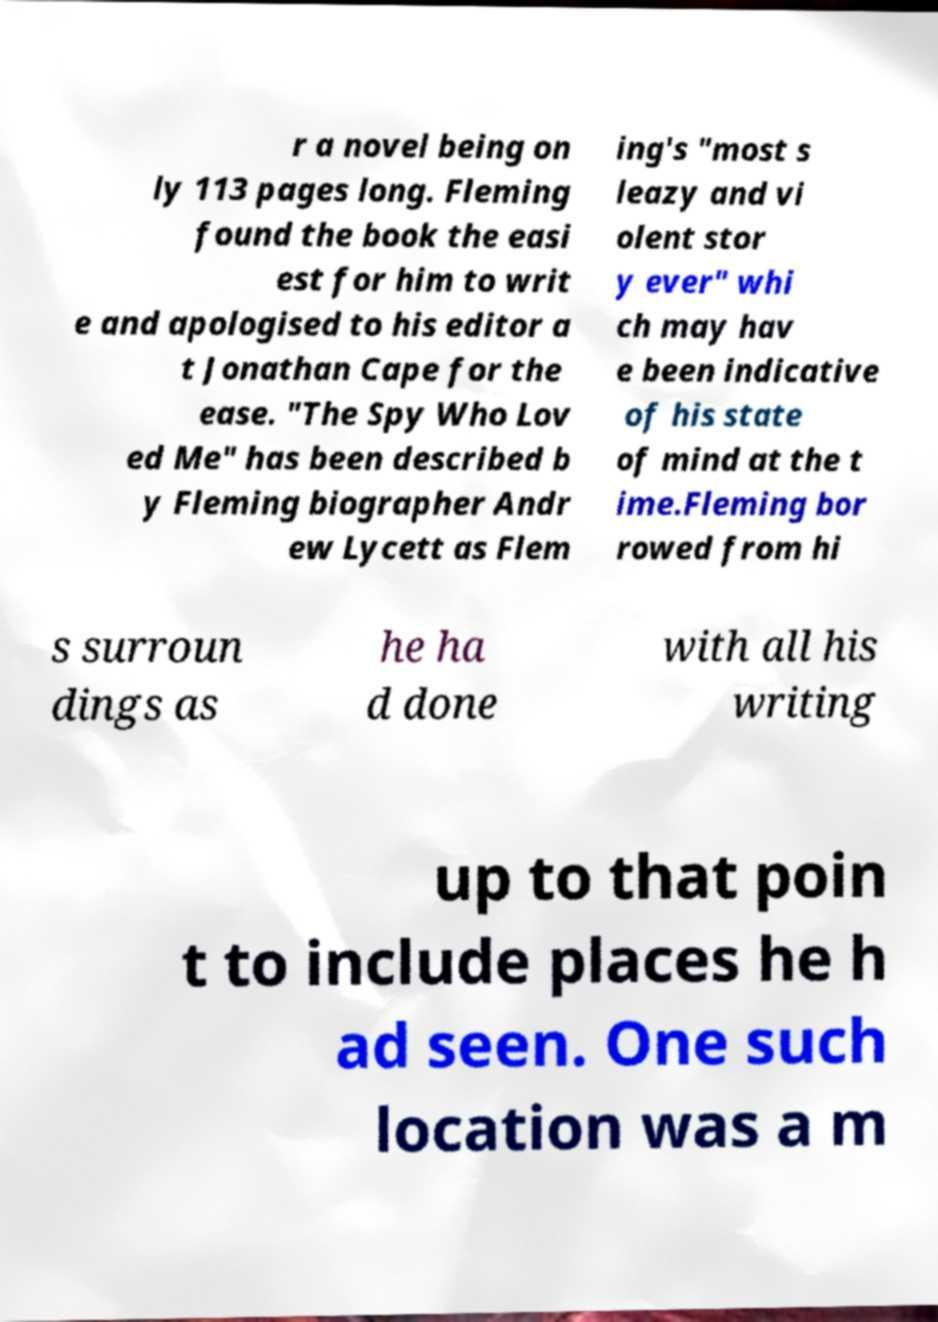Can you accurately transcribe the text from the provided image for me? r a novel being on ly 113 pages long. Fleming found the book the easi est for him to writ e and apologised to his editor a t Jonathan Cape for the ease. "The Spy Who Lov ed Me" has been described b y Fleming biographer Andr ew Lycett as Flem ing's "most s leazy and vi olent stor y ever" whi ch may hav e been indicative of his state of mind at the t ime.Fleming bor rowed from hi s surroun dings as he ha d done with all his writing up to that poin t to include places he h ad seen. One such location was a m 